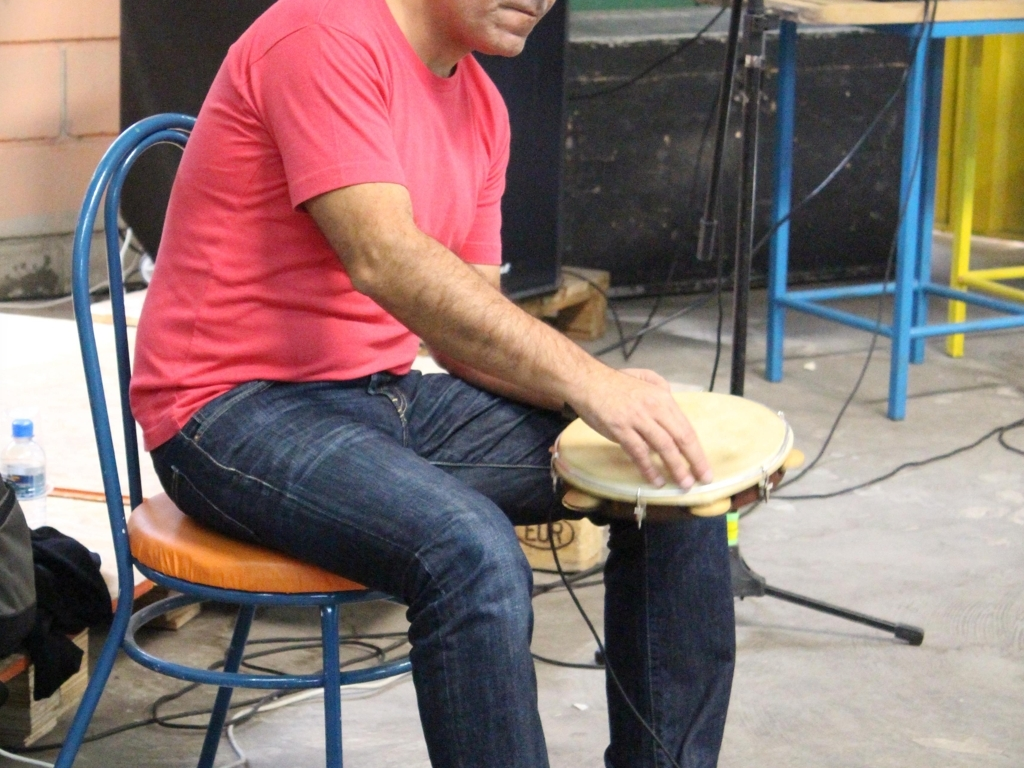What type of instrument is the person playing? The person is playing a pandeiro, which is a type of hand-held drum often used in Brazilian music. Can you tell me more about the pandeiro? Certainly! The pandeiro is a versatile percussion instrument resembling a tambourine. It consists of a circular wooden or plastic frame with a drumhead made of nylon or animal skin. It's played by striking it with the hand or fingers to produce different rhythms and tones, and it’s commonly associated with samba, capoeira, and other Brazilian musical styles. Its portability and diverse sound make it a beloved instrument in many cultural celebrations and musical genres. 